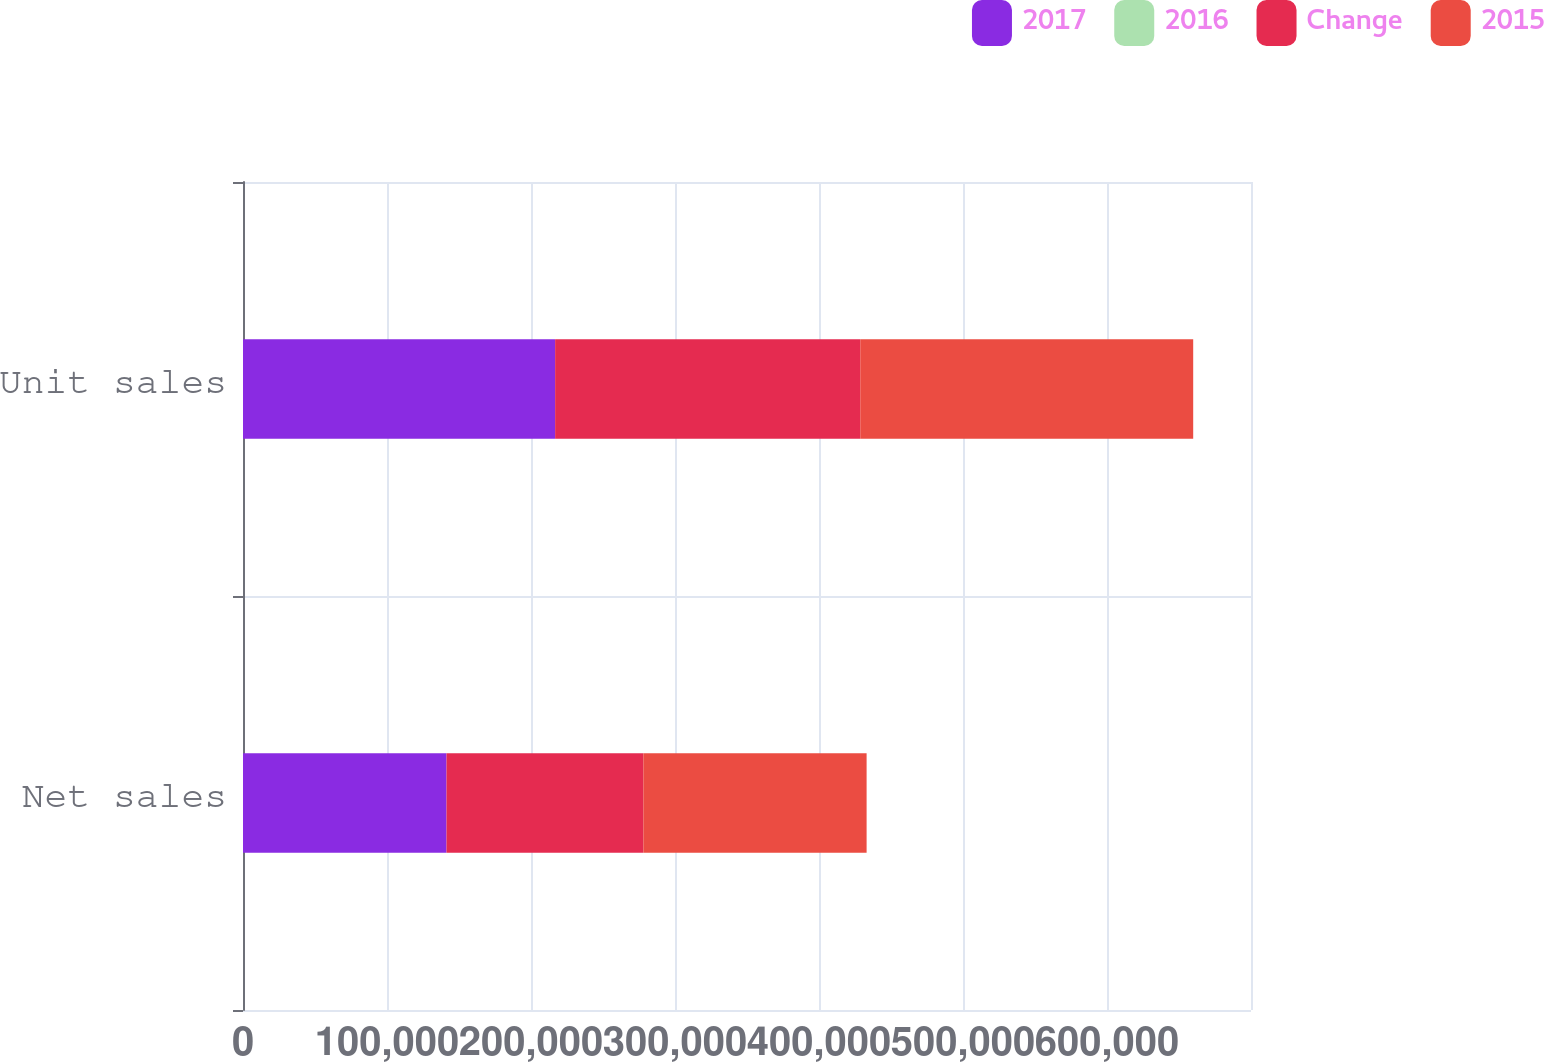Convert chart. <chart><loc_0><loc_0><loc_500><loc_500><stacked_bar_chart><ecel><fcel>Net sales<fcel>Unit sales<nl><fcel>2017<fcel>141319<fcel>216756<nl><fcel>2016<fcel>3<fcel>2<nl><fcel>Change<fcel>136700<fcel>211884<nl><fcel>2015<fcel>155041<fcel>231218<nl></chart> 